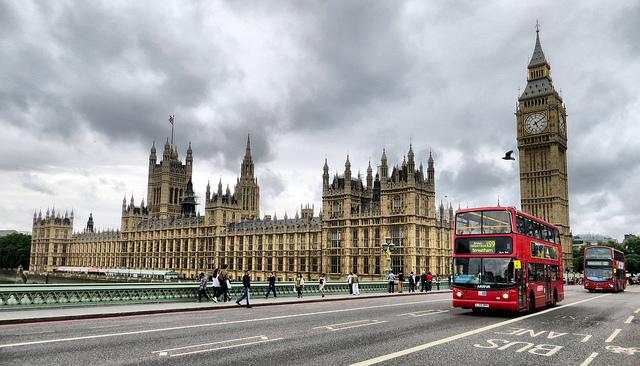How many people are in the bus?
Quick response, please. 25. Are the buses in the bus lane?
Give a very brief answer. No. What city is this?
Concise answer only. London. 